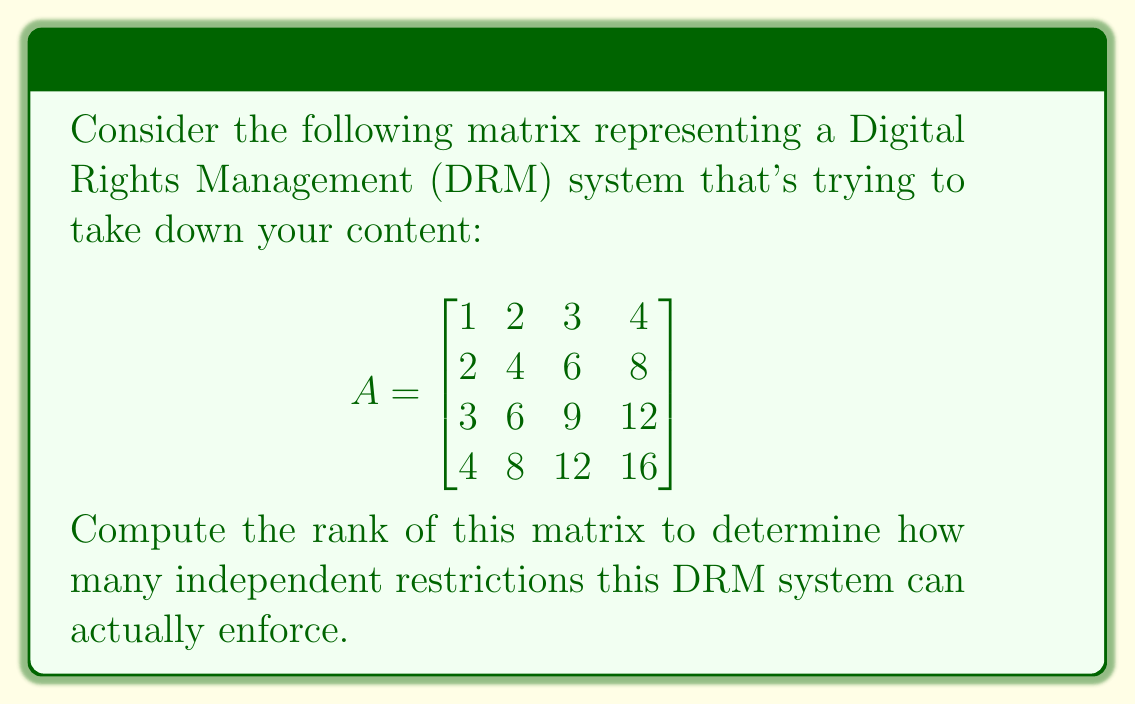Give your solution to this math problem. To find the rank of matrix A, we'll use the following steps:

1) First, let's convert the matrix to row echelon form using Gaussian elimination:

$$
\begin{bmatrix}
1 & 2 & 3 & 4 \\
2 & 4 & 6 & 8 \\
3 & 6 & 9 & 12 \\
4 & 8 & 12 & 16
\end{bmatrix} \sim
\begin{bmatrix}
1 & 2 & 3 & 4 \\
0 & 0 & 0 & 0 \\
0 & 0 & 0 & 0 \\
0 & 0 & 0 & 0
\end{bmatrix}
$$

2) The rank of a matrix is equal to the number of non-zero rows in its row echelon form.

3) In this case, we can see that there is only one non-zero row in the row echelon form.

4) This means that all other rows are linear combinations of the first row, implying that the DRM system's restrictions are not as comprehensive as they might appear.

5) Therefore, the rank of the matrix is 1.
Answer: 1 